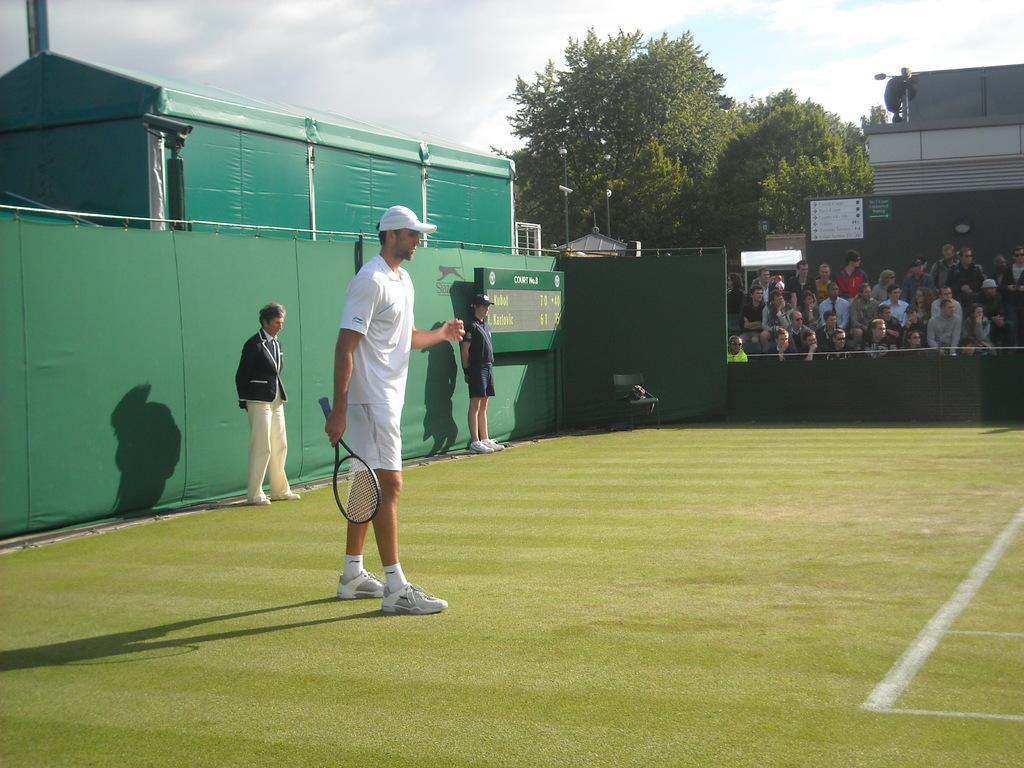In one or two sentences, can you explain what this image depicts? In the image there is a man with tennis bat stood on grass field and at the left side there are audience looking at the game and this a tennis game going on. And at the background there are trees ,over the top there is sky filled with clouds. 